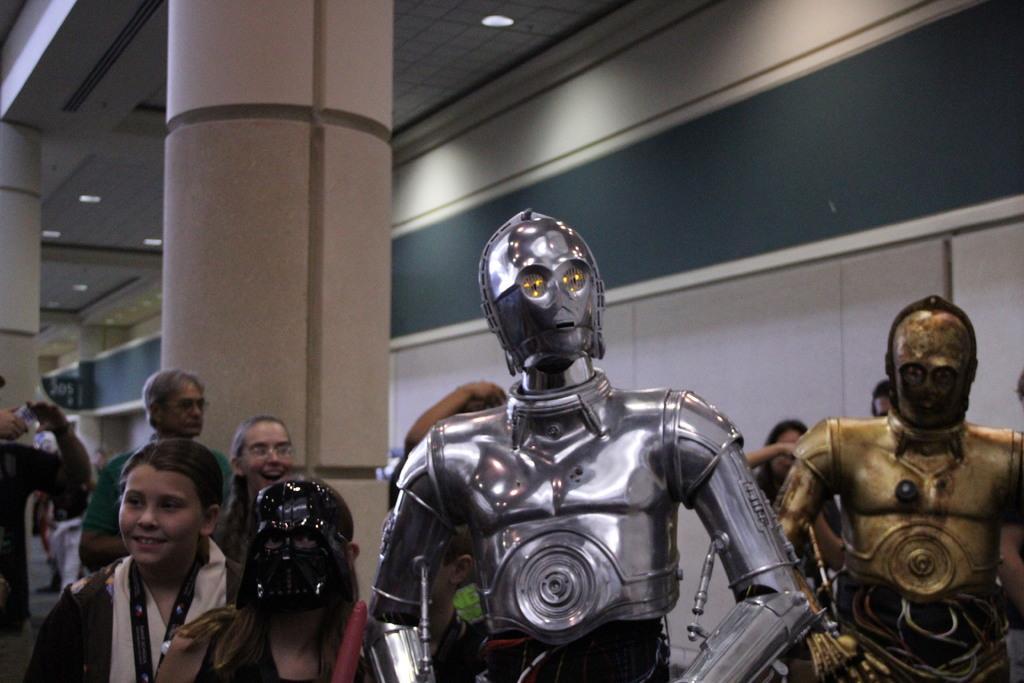Could you give a brief overview of what you see in this image? In this image there are two robots. In the background there are many people. On the ceiling there are lights. Here there are pillars. 